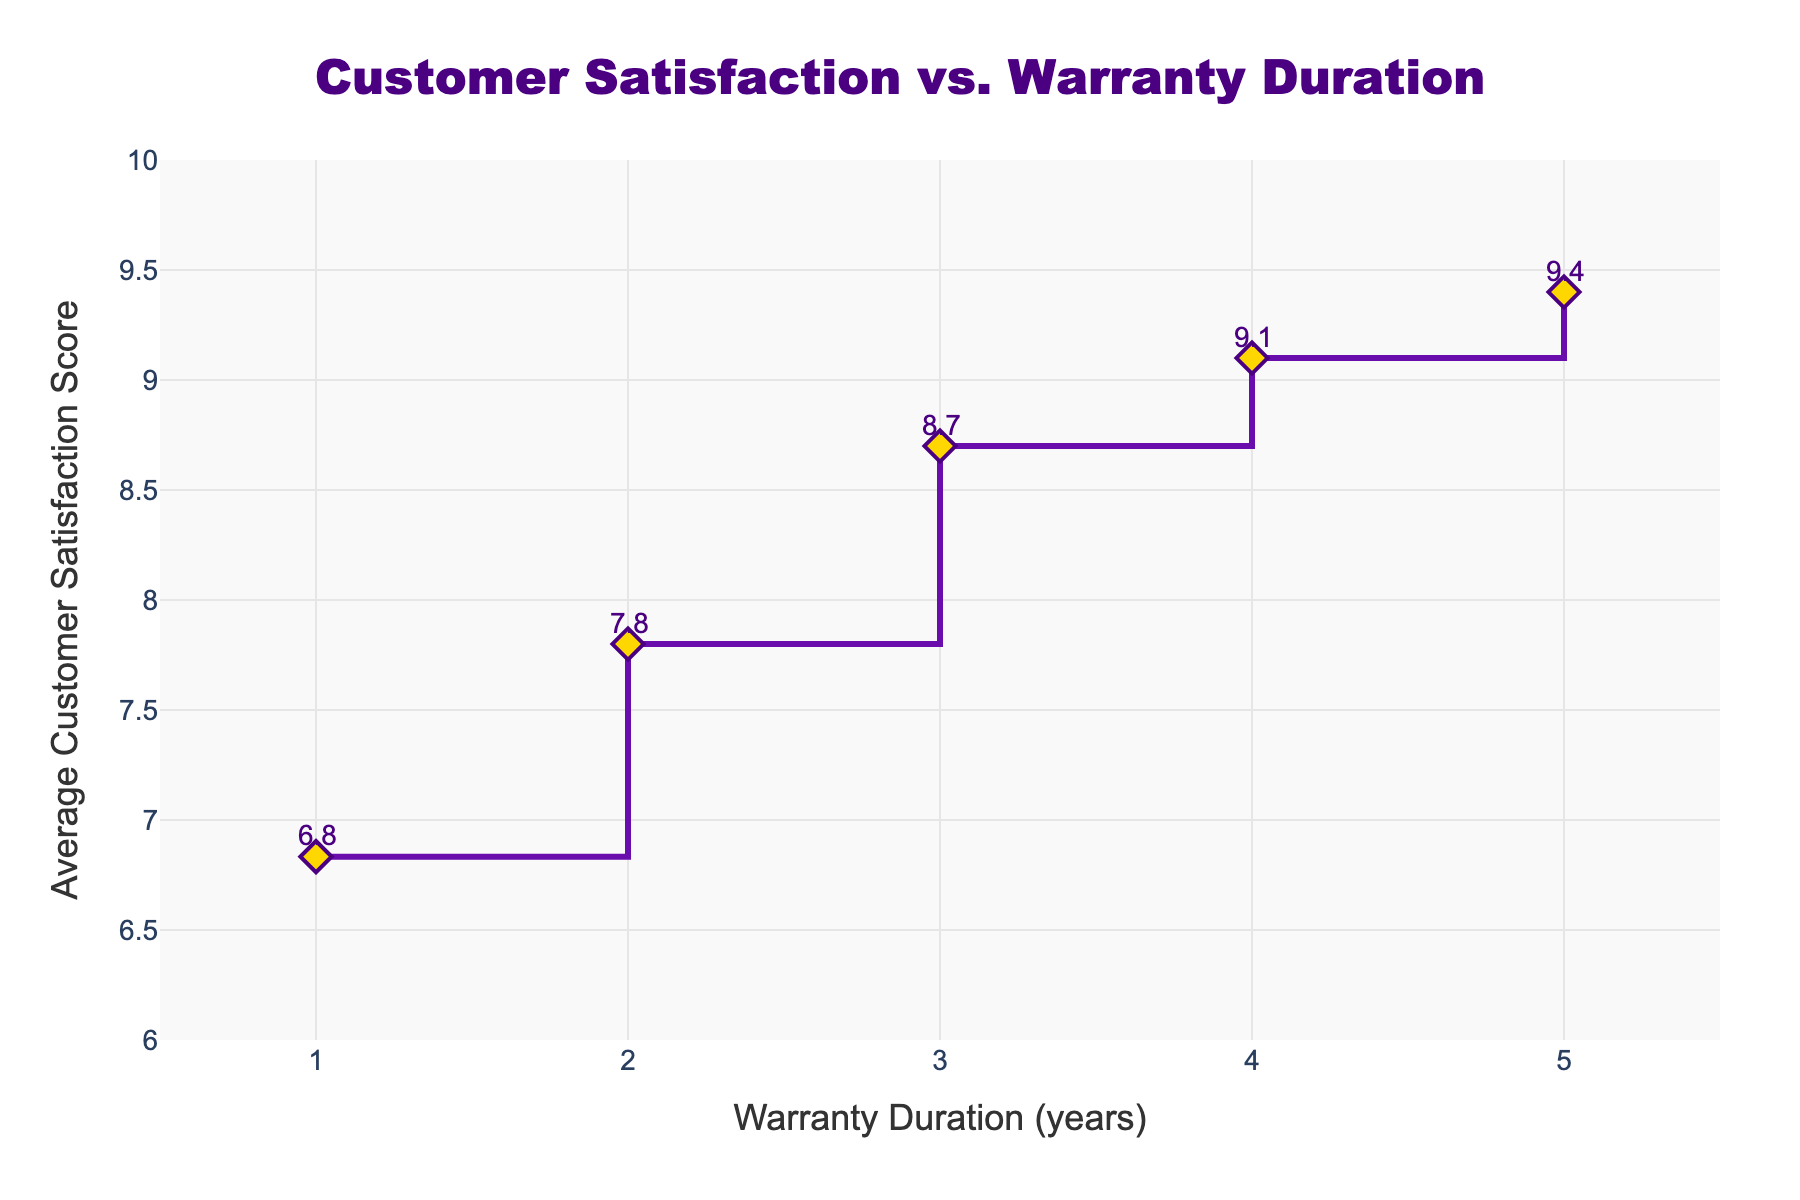What is the title of the figure? The title of the figure can be found at the top center of the plot. It reads "Customer Satisfaction vs. Warranty Duration".
Answer: Customer Satisfaction vs. Warranty Duration Which warranty duration has the highest average customer satisfaction score? The plot shows satisfaction scores for different warranty durations, with the highest score at a warranty duration of 5 years. The corresponding satisfaction score here is the highest.
Answer: 5 years How does the average customer satisfaction score change as the warranty duration increases from 1 to 5 years? Observing the plot, the customer satisfaction score increases consistently as the warranty duration increases from 1 to 5 years. Each step in warranty duration shows an increase in the satisfaction score.
Answer: It increases What is the average customer satisfaction score for a 3-year warranty duration? By looking at the data point on the plot aligned with the 3-year mark on the x-axis, the average customer satisfaction score can be identified as around 8.7.
Answer: 8.7 What is the difference in average customer satisfaction score between a 4-year and a 2-year warranty duration? From the plot, the satisfaction score for a 4-year warranty is 9.1 and for a 2-year warranty is 7.8. The difference would be 9.1 - 7.8.
Answer: 1.3 Does the satisfaction score ever decrease as the warranty duration increases? The plot shows a steady increase in satisfaction scores up to the 5-year mark, with no drops in the values.
Answer: No What is the average customer satisfaction score for a 1-year warranty duration? The average score for a 1-year warranty can be seen on the plot near the 1-year mark on the x-axis. It's approximately 6.8.
Answer: 6.8 Compare the average customer satisfaction scores for 1-year and 5-year warranty durations. The plot shows the satisfaction score for 1-year at approximately 6.8 and for 5-year at approximately 9.4. The 5-year warranty has a significantly higher score.
Answer: 5-year has higher score Which warranty duration shows the most significant improvement in customer satisfaction score from the previous duration? The largest jump in satisfaction scores can be observed between 2-year and 3-year warranty durations, based on the steepness of the stair plot steps.
Answer: Between 2-year and 3-year Is there any visual element that represents the exact average scores for each warranty duration in the plot? Yes, the plot has annotations above each point that show the exact average satisfaction scores for each warranty duration.
Answer: Yes 